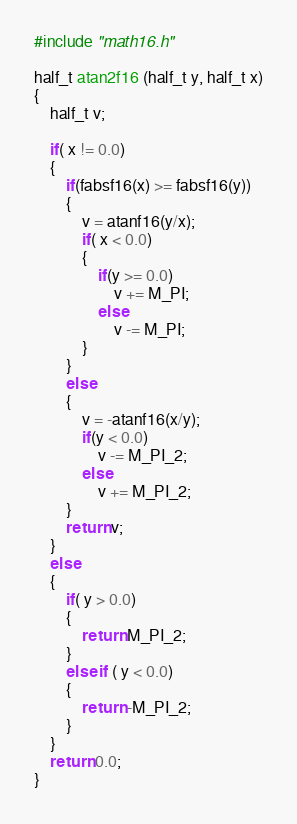<code> <loc_0><loc_0><loc_500><loc_500><_C_>
#include "math16.h"

half_t atan2f16 (half_t y, half_t x)
{
    half_t v;

    if( x != 0.0)
    {
        if(fabsf16(x) >= fabsf16(y))
        {
            v = atanf16(y/x);
            if( x < 0.0)
            {
                if(y >= 0.0)
                    v += M_PI;
                else
                    v -= M_PI;
            }
        }
        else
        {
            v = -atanf16(x/y);
            if(y < 0.0)
                v -= M_PI_2;
            else
                v += M_PI_2;
        }
        return v;
    }
    else
    {
        if( y > 0.0)
        {
            return M_PI_2;
        }
        else if ( y < 0.0)
        {
            return -M_PI_2;
        }
    }
    return 0.0;
}

</code> 